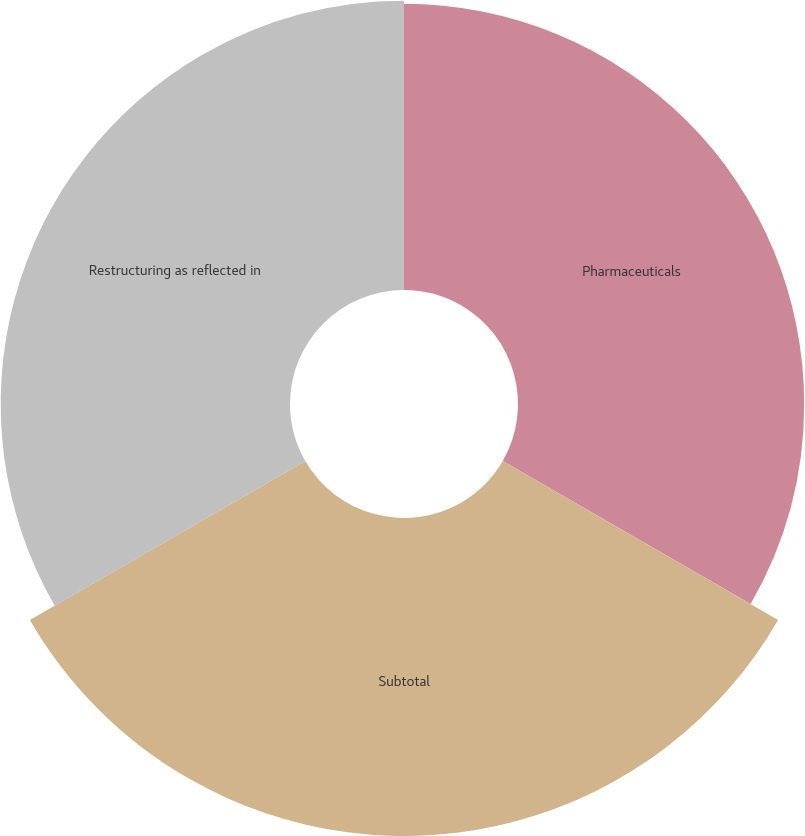<chart> <loc_0><loc_0><loc_500><loc_500><pie_chart><fcel>Pharmaceuticals<fcel>Subtotal<fcel>Restructuring as reflected in<nl><fcel>32.03%<fcel>35.59%<fcel>32.38%<nl></chart> 